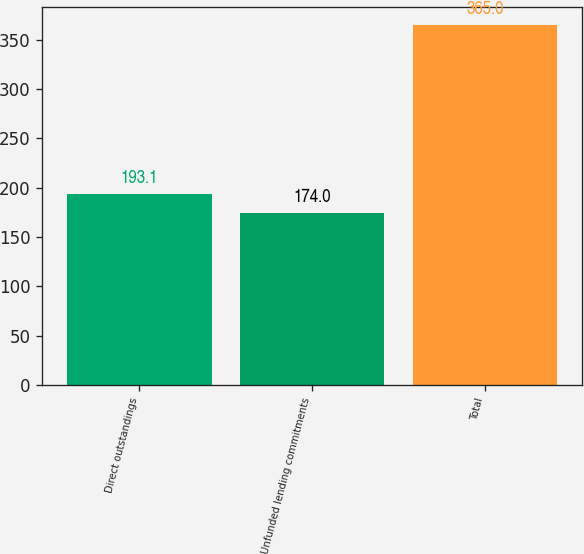Convert chart to OTSL. <chart><loc_0><loc_0><loc_500><loc_500><bar_chart><fcel>Direct outstandings<fcel>Unfunded lending commitments<fcel>Total<nl><fcel>193.1<fcel>174<fcel>365<nl></chart> 